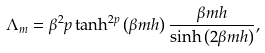Convert formula to latex. <formula><loc_0><loc_0><loc_500><loc_500>\Lambda _ { m } = \beta ^ { 2 } p \tanh ^ { 2 p } \left ( \beta m h \right ) \frac { \beta m h } { \sinh \left ( 2 \beta m h \right ) } ,</formula> 